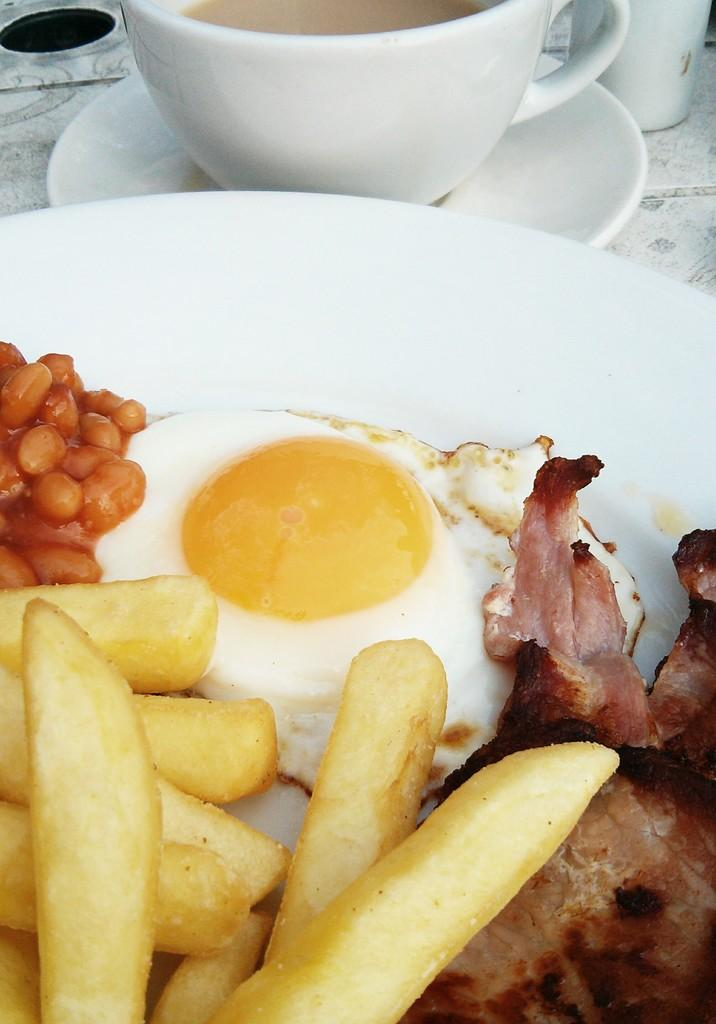What is on the plate in the image? There are food items on a plate in the image. What is the cup resting on in the image? There is a cup on a saucer in the image. Can you describe the object on the table in the image? There is an object on the table in the image, but its specific nature is not mentioned in the provided facts. What type of behavior is exhibited by the knee in the image? There is no knee present in the image, so it is not possible to determine any behavior. 